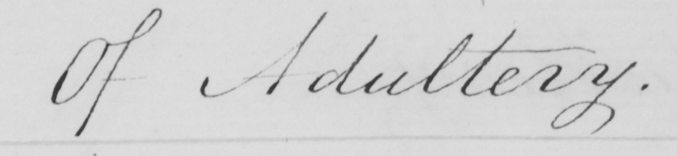Please transcribe the handwritten text in this image. Of Adultery . 